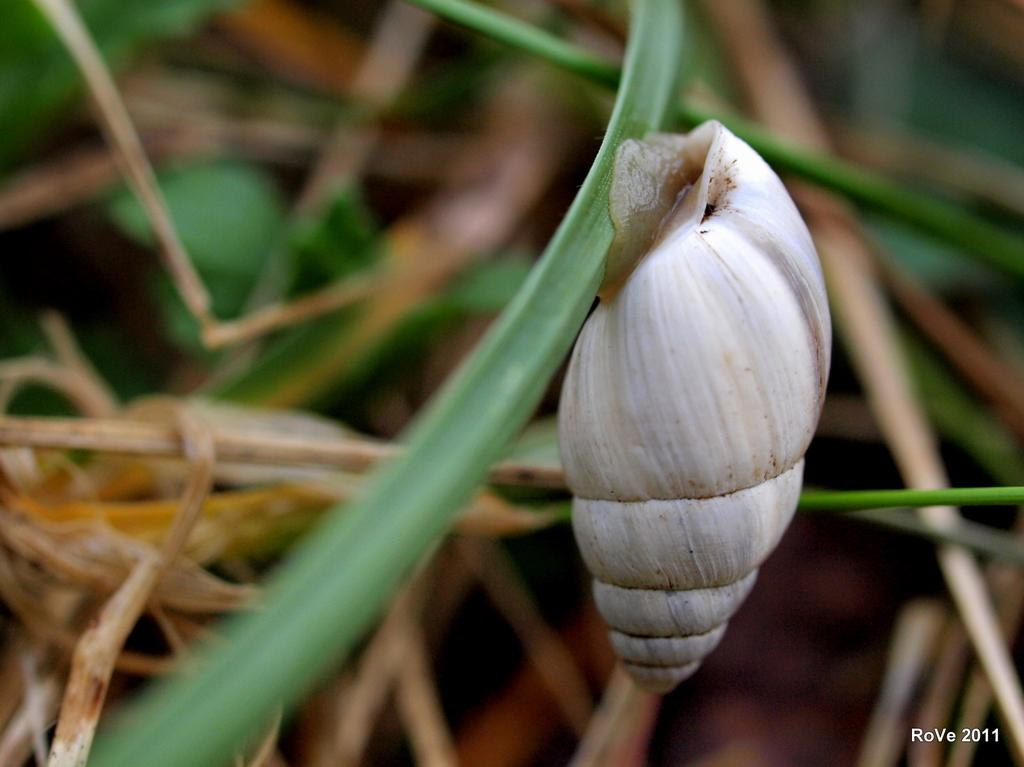What object is located on the right side of the image? There is a shell on the right side of the image. What else can be seen in the bottom right side of the image? There is text in the bottom right side of the image. How would you describe the background of the image? The background of the image is blurred. What type of hammer can be seen near the volcano in the image? There is no hammer or volcano present in the image. How many days are in the week depicted in the image? There is no reference to a week or any days in the image. 